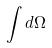<formula> <loc_0><loc_0><loc_500><loc_500>\int d \Omega</formula> 